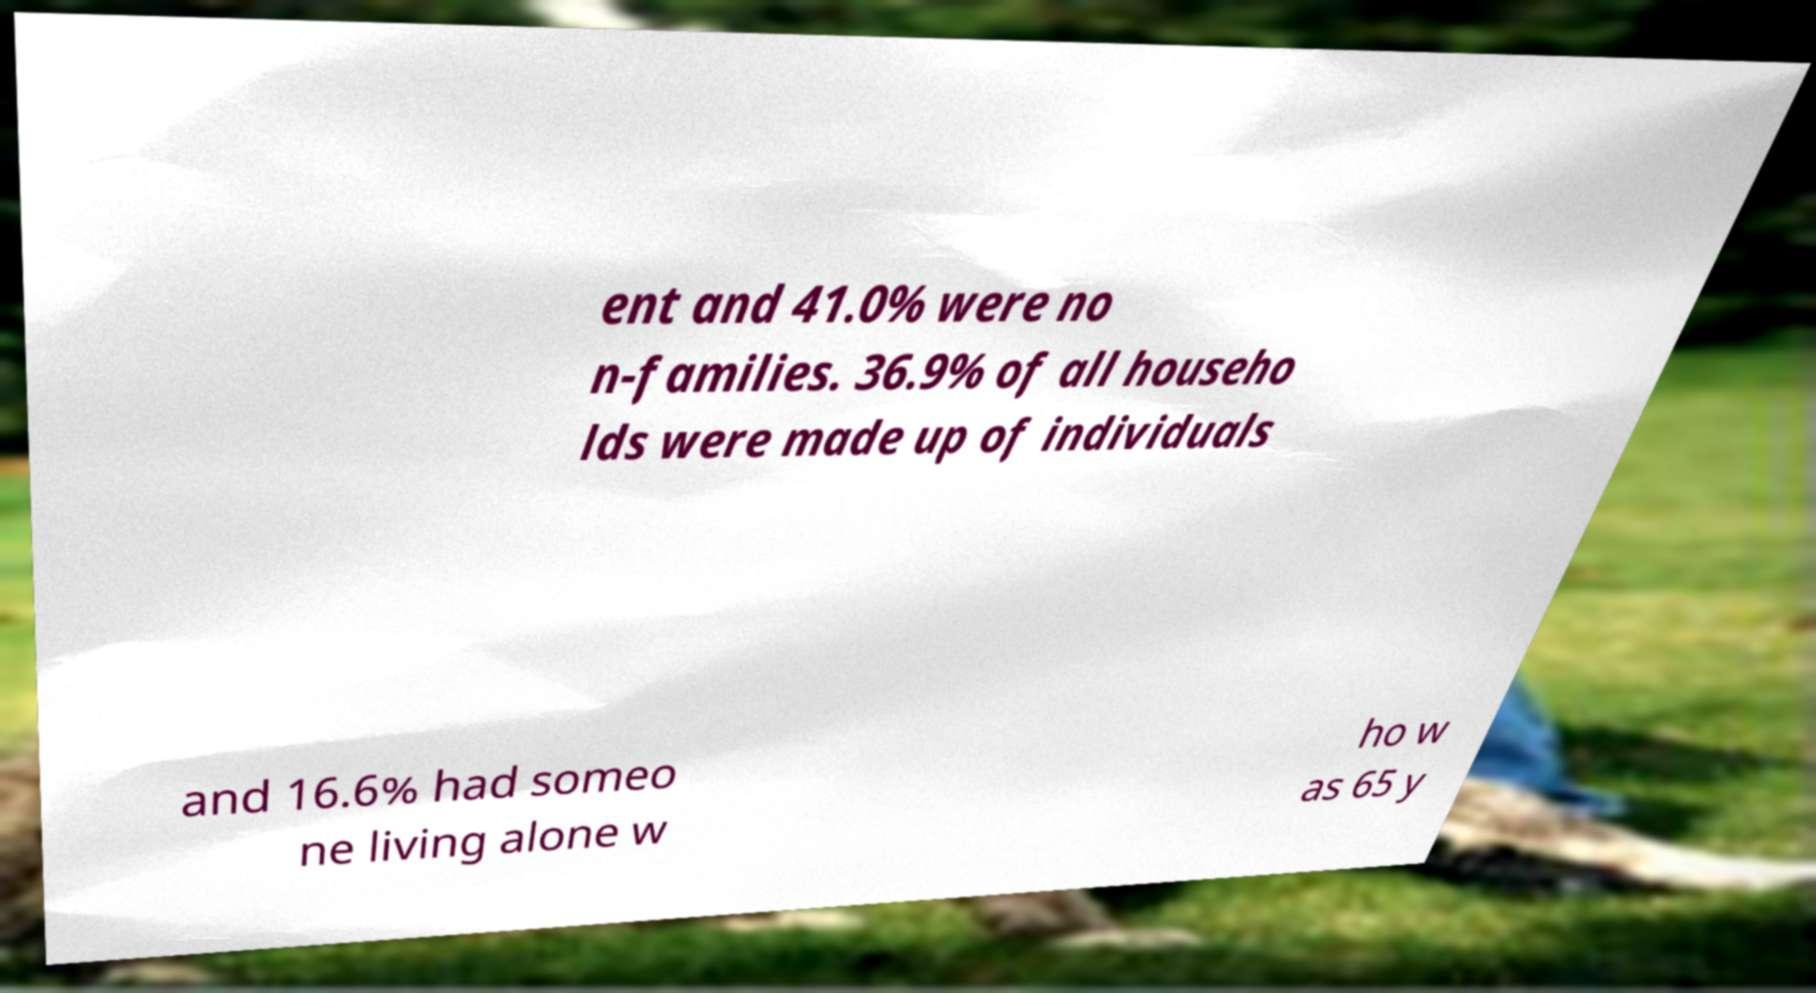Could you extract and type out the text from this image? ent and 41.0% were no n-families. 36.9% of all househo lds were made up of individuals and 16.6% had someo ne living alone w ho w as 65 y 